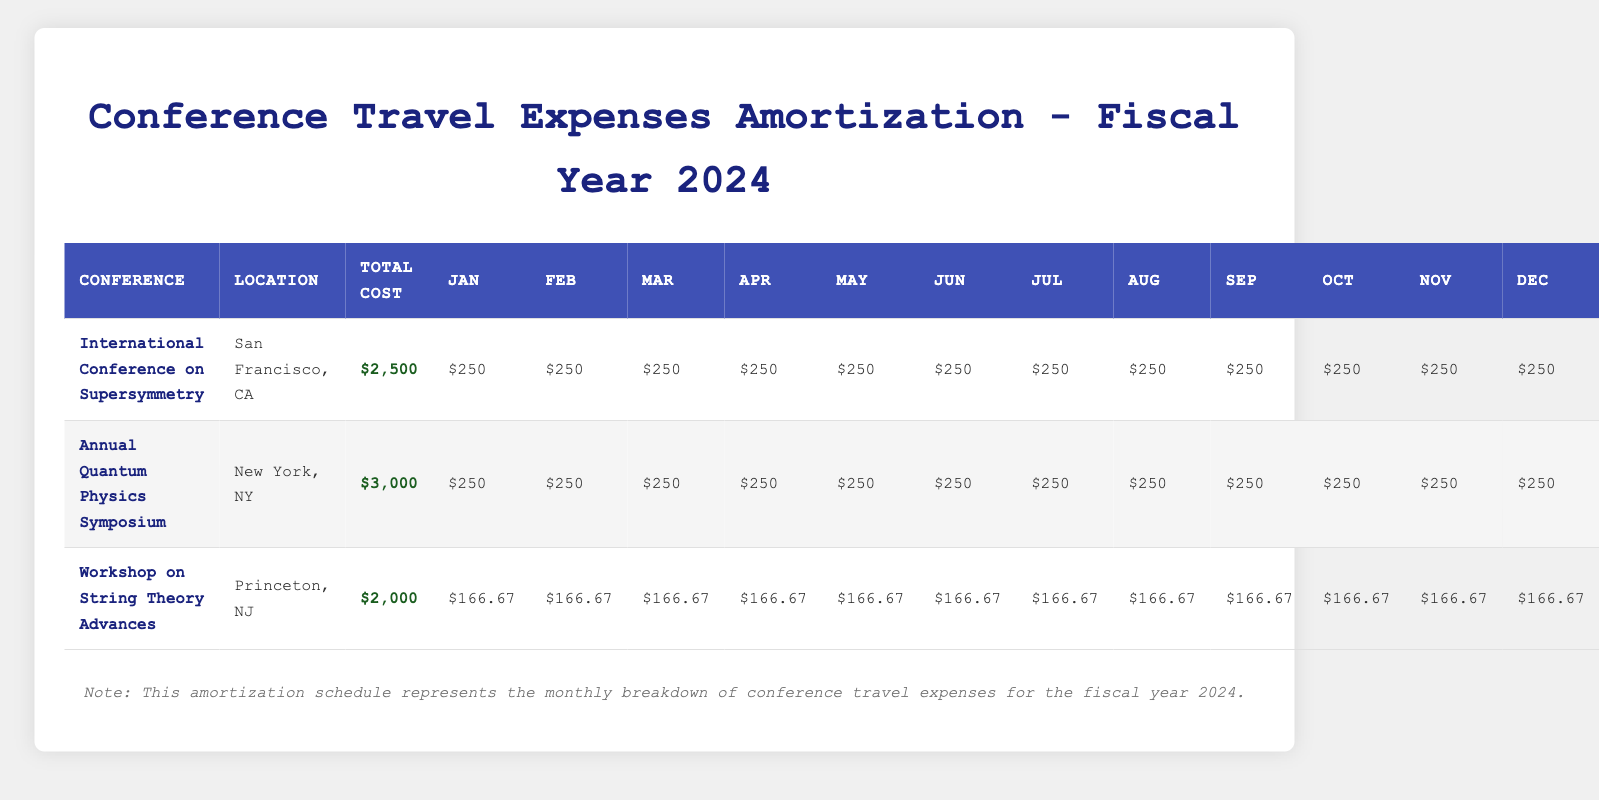What is the total cost of the International Conference on Supersymmetry? The total cost listed in the table for the International Conference on Supersymmetry is $2,500, which can be directly retrieved from the corresponding column.
Answer: $2,500 How much will be spent on meals for the Annual Quantum Physics Symposium? The cost breakdown in the table shows that meals for the Annual Quantum Physics Symposium amount to $500, which is explicitly provided in the cost breakdown section.
Answer: $500 Which conference has the highest total cost? The total costs of the conferences are as follows: $2,500 for the International Conference on Supersymmetry, $3,000 for the Annual Quantum Physics Symposium, and $2,000 for the Workshop on String Theory Advances. By comparing these, the highest is $3,000 for the Annual Quantum Physics Symposium.
Answer: Annual Quantum Physics Symposium What is the average monthly amortization amount for the Workshop on String Theory Advances? The total cost for the Workshop on String Theory Advances is $2,000, to be amortized over 12 months. Dividing the total cost by the number of months gives: 2000 / 12 = 166.67. Thus, the average is approximately $166.67 per month.
Answer: $166.67 Is the amortization amount for any conference the same across all months? Looking at the amortization schedules, both the International Conference on Supersymmetry and the Annual Quantum Physics Symposium have consistent monthly amounts of $250 throughout the year. Thus, the answer is yes.
Answer: Yes What is the total of local transportation costs for all conferences combined? The local transportation costs are as follows: $200 for the International Conference on Supersymmetry, $300 for the Annual Quantum Physics Symposium, and $150 for the Workshop on String Theory Advances. Adding these gives 200 + 300 + 150 = 650, which is the total local transportation cost across all conferences.
Answer: $650 What percentage of the total cost of the Workshop on String Theory Advances is allocated to accommodation? The accommodation cost for the Workshop is $700 and the total cost is $2,000. The percentage allocation can be calculated as (700 / 2000) * 100 = 35%. Thus, 35% of the total cost is for accommodation.
Answer: 35% Compare the monthly amortization amounts of the two conferences located in major cities (San Francisco and New York). Both the International Conference on Supersymmetry and the Annual Quantum Physics Symposium have monthly amortization amounts of $250 each. Their amounts are equal, making their comparison straightforward.
Answer: They are equal 